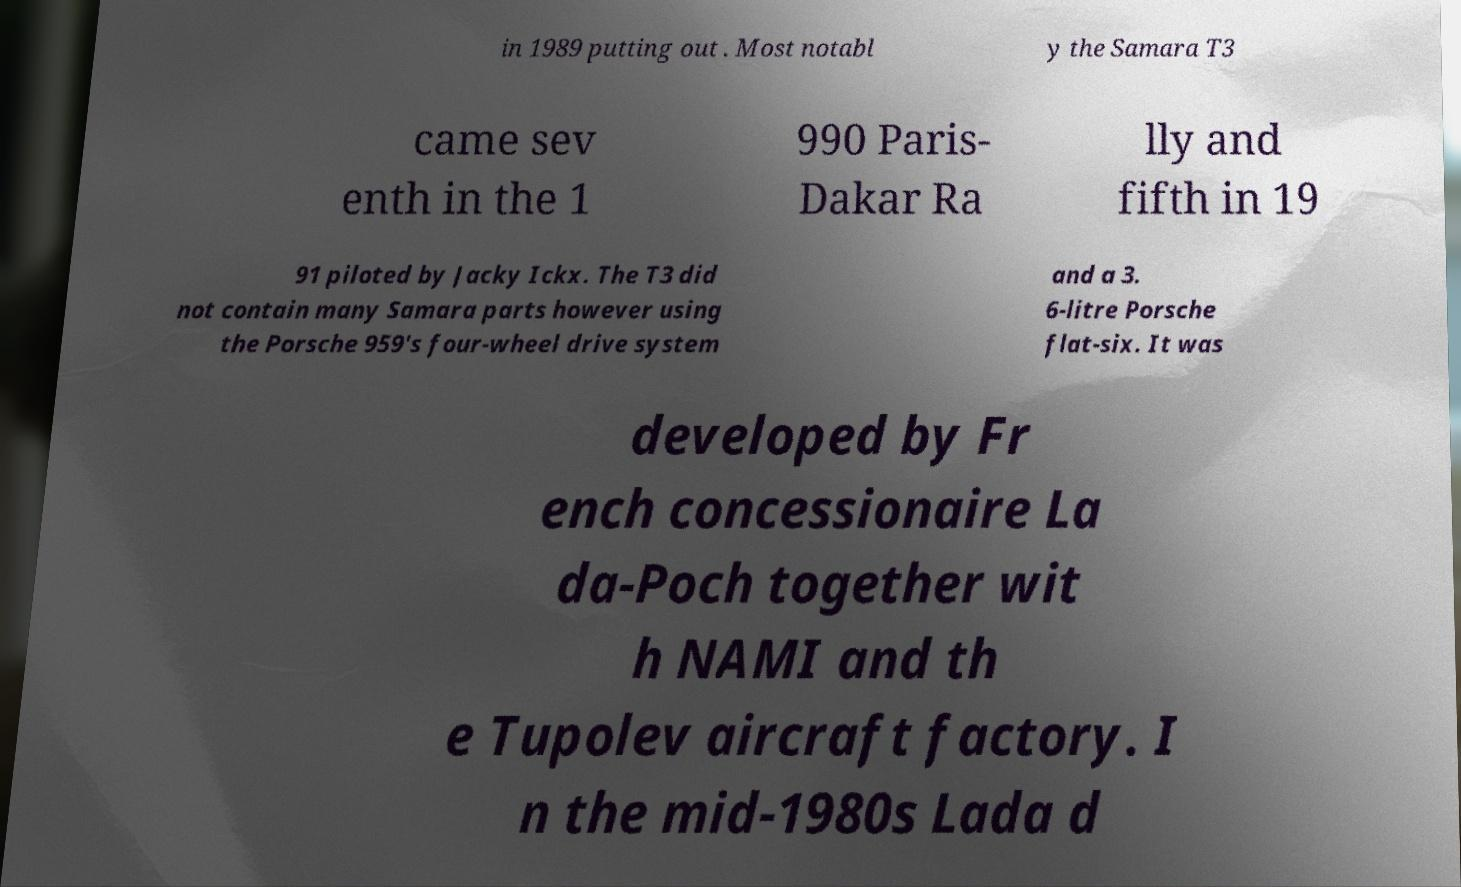For documentation purposes, I need the text within this image transcribed. Could you provide that? in 1989 putting out . Most notabl y the Samara T3 came sev enth in the 1 990 Paris- Dakar Ra lly and fifth in 19 91 piloted by Jacky Ickx. The T3 did not contain many Samara parts however using the Porsche 959's four-wheel drive system and a 3. 6-litre Porsche flat-six. It was developed by Fr ench concessionaire La da-Poch together wit h NAMI and th e Tupolev aircraft factory. I n the mid-1980s Lada d 